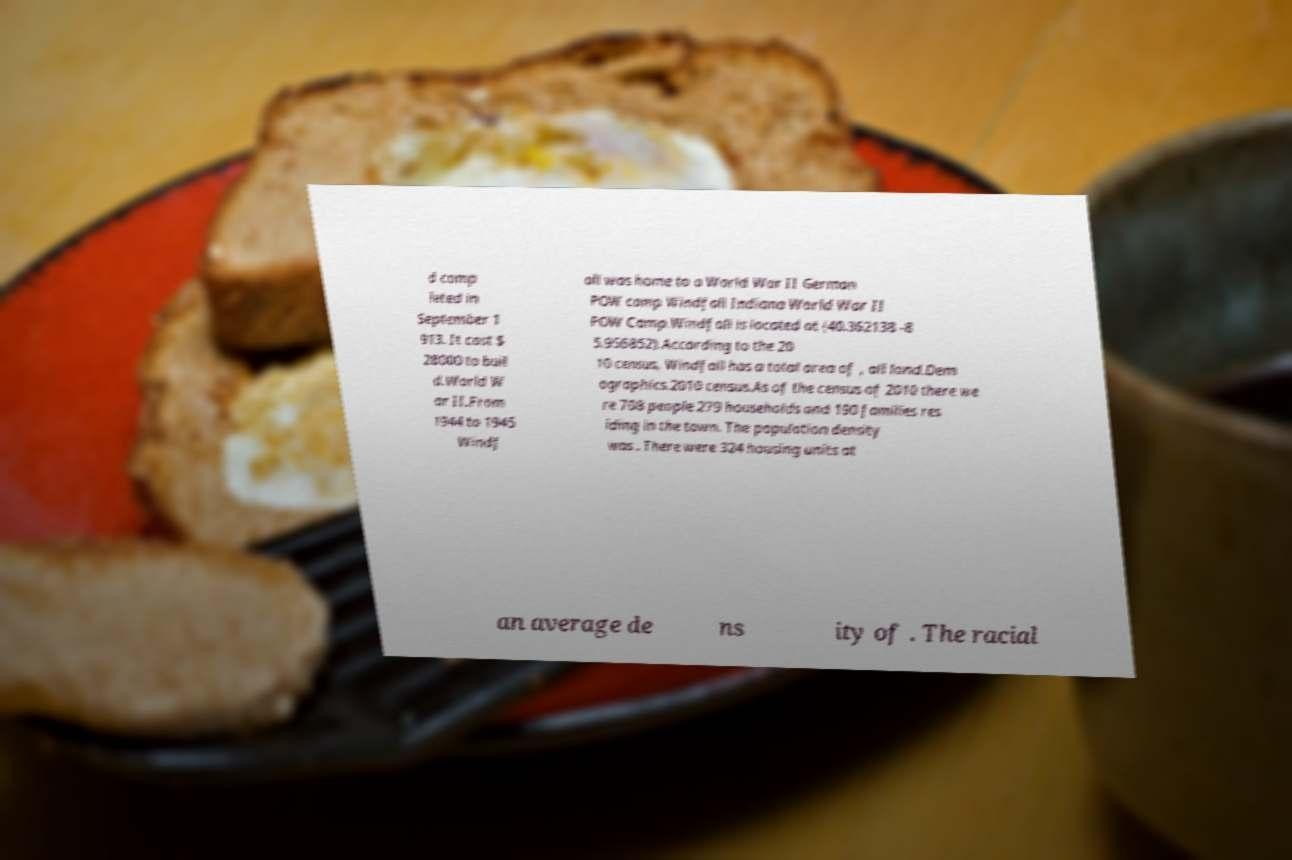Please identify and transcribe the text found in this image. d comp leted in September 1 913. It cost $ 28000 to buil d.World W ar II.From 1944 to 1945 Windf all was home to a World War II German POW camp Windfall Indiana World War II POW Camp.Windfall is located at (40.362138 -8 5.956852).According to the 20 10 census, Windfall has a total area of , all land.Dem ographics.2010 census.As of the census of 2010 there we re 708 people 279 households and 190 families res iding in the town. The population density was . There were 324 housing units at an average de ns ity of . The racial 